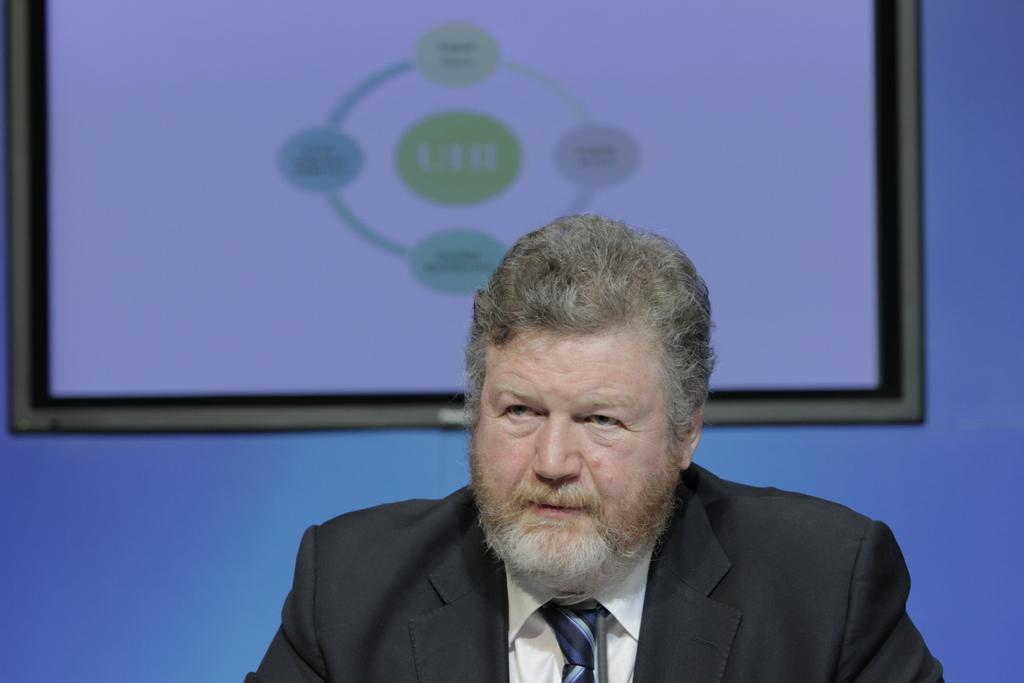Who is present in the image? There is a man in the image. What is the man wearing? The man is wearing a suit. What can be seen behind the man? There is a screen behind the man. What type of hair is the man wearing in the image? The provided facts do not mention anything about the man's hair, so we cannot determine the type of hair he is wearing. 